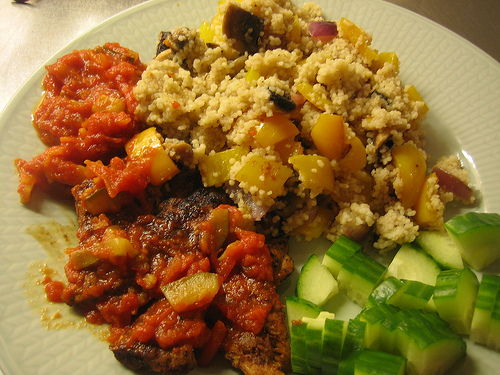<image>
Is there a cucumber under the plate? No. The cucumber is not positioned under the plate. The vertical relationship between these objects is different. Is the foods in front of the cooked? Yes. The foods is positioned in front of the cooked, appearing closer to the camera viewpoint. 